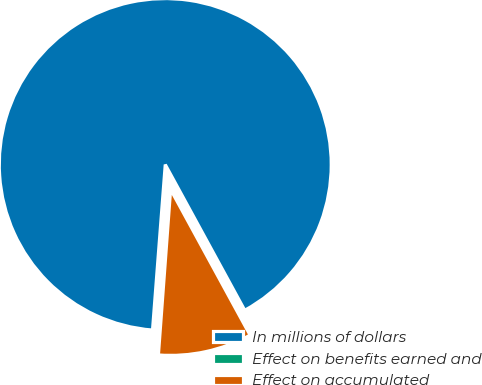Convert chart. <chart><loc_0><loc_0><loc_500><loc_500><pie_chart><fcel>In millions of dollars<fcel>Effect on benefits earned and<fcel>Effect on accumulated<nl><fcel>90.83%<fcel>0.05%<fcel>9.12%<nl></chart> 